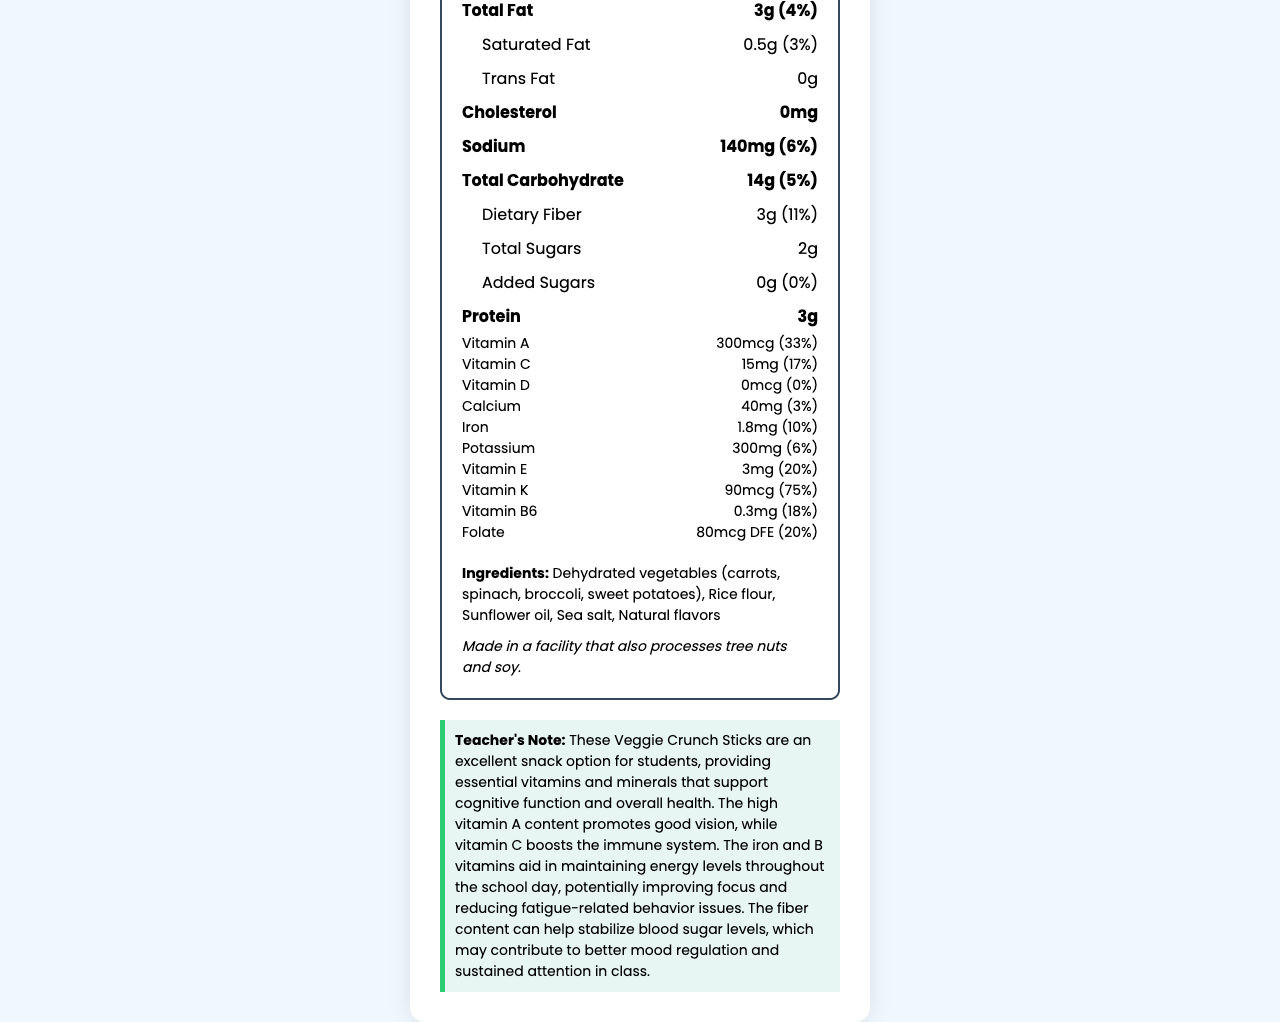what is the serving size for Super Veggie Crunch Sticks? The serving size is specified at the top of the nutrition label.
Answer: 1 package (28g) how many calories are in one package? The calories are listed prominently under the "Calories" section.
Answer: 90 calories what is the total fat content and its daily value percentage? The total fat content is 3 grams and its daily value percentage is 4%.
Answer: 3g (4%) how much dietary fiber is in the snack? The amount of dietary fiber is listed as 3 grams.
Answer: 3g how much vitamin A does this snack provide, and what percentage of the daily value is this? The snack provides 300mcg of vitamin A, which is 33% of the daily value.
Answer: 300mcg (33%) how much sodium is in one serving of Super Veggie Crunch Sticks? The amount of sodium per serving is stated as 140 milligrams.
Answer: 140mg list the main ingredients of the Super Veggie Crunch Sticks. The main ingredients are listed at the end of the document.
Answer: Dehydrated vegetables (carrots, spinach, broccoli, sweet potatoes), Rice flour, Sunflower oil, Sea salt, Natural flavors what is the purpose of vitamin B6 in the diet? The teacher's note states that B vitamins, including B6, aid in maintaining energy levels throughout the school day, improving focus and reducing fatigue-related issues.
Answer: Vitamin B6 helps in maintaining energy levels and is essential for brain health. are there any added sugars in the snack? The amount of added sugars is specified as 0 grams.
Answer: No what is the main benefit of the high dietary fiber content? The teacher's note suggests that the high fiber content can help stabilize blood sugar levels which may improve mood regulation and attention.
Answer: Stabilizes blood sugar levels and can contribute to mood regulation and sustained attention. which of the following vitamins is present in the highest percentage of daily value in Super Veggie Crunch Sticks?
A. Vitamin C
B. Vitamin K
C. Vitamin A
D. Vitamin E Vitamin K is present at 75% of the daily value, which is higher than the other listed options.
Answer: B. Vitamin K what is the daily value percentage of iron in the snack?
I. 3%
II. 6%
III. 10%
IV. 20% The daily value percentage for iron is stated as 10% on the nutrition label.
Answer: III. 10% does the snack contain any cholesterol? The amount of cholesterol is specified as 0 milligrams.
Answer: No summarize the main benefits of Super Veggie Crunch Sticks as described in the teacher's note. The teacher's note highlights the snack's benefits, including improved vision, immune support, energy levels, focus, and mood regulation.
Answer: The Super Veggie Crunch Sticks are nutrient-dense and provide essential vitamins and minerals that aid cognitive function and overall health. They are rich in vitamin A, which supports good vision, and vitamin C, which boosts the immune system. The iron and B vitamins help maintain energy levels and improve focus, while the high fiber content helps stabilize blood sugar, contributing to better mood regulation and sustained attention in class. how much vitamin D is in the Super Veggie Crunch Sticks? The label specifies 0 micrograms of vitamin D, providing 0% of the daily value.
Answer: Not enough information what is the daily value percentage of calcium in the snack? The calcium content has 3% of the daily value specified in the nutrition information.
Answer: 3% do the Super Veggie Crunch Sticks contain any allergens? If yes, what are they? The allergen information mentions that it is made in a facility that also processes tree nuts and soy.
Answer: Made in a facility that also processes tree nuts and soy. 